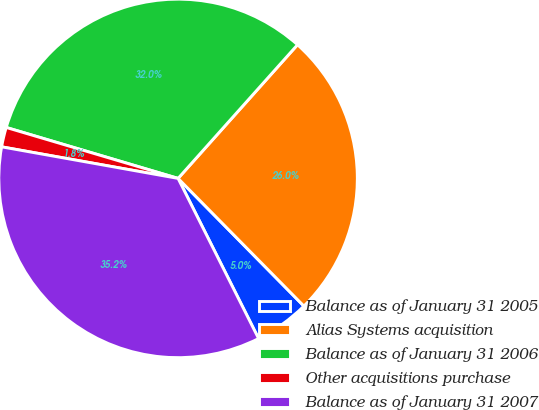Convert chart to OTSL. <chart><loc_0><loc_0><loc_500><loc_500><pie_chart><fcel>Balance as of January 31 2005<fcel>Alias Systems acquisition<fcel>Balance as of January 31 2006<fcel>Other acquisitions purchase<fcel>Balance as of January 31 2007<nl><fcel>4.97%<fcel>26.01%<fcel>32.02%<fcel>1.77%<fcel>35.23%<nl></chart> 